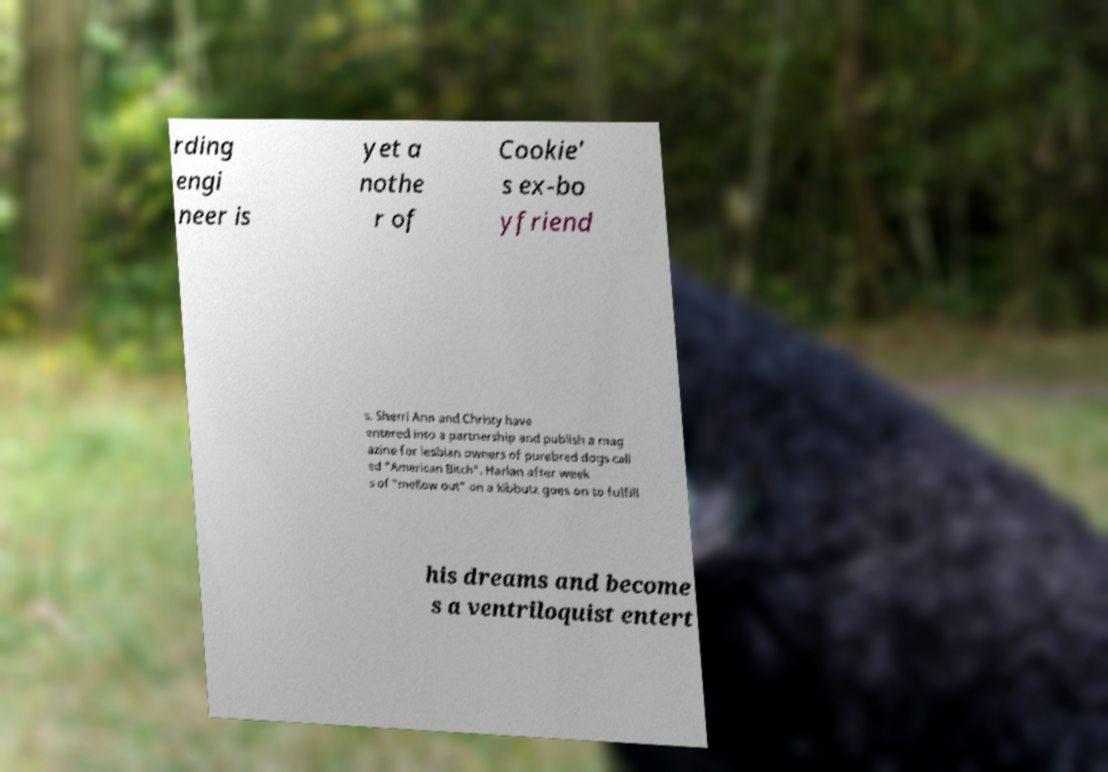Can you read and provide the text displayed in the image?This photo seems to have some interesting text. Can you extract and type it out for me? rding engi neer is yet a nothe r of Cookie' s ex-bo yfriend s. Sherri Ann and Christy have entered into a partnership and publish a mag azine for lesbian owners of purebred dogs call ed "American Bitch". Harlan after week s of "mellow out" on a kibbutz goes on to fulfill his dreams and become s a ventriloquist entert 